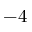Convert formula to latex. <formula><loc_0><loc_0><loc_500><loc_500>- 4</formula> 